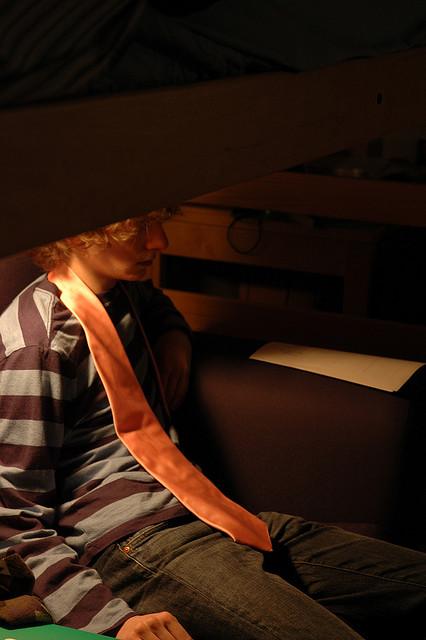What color is the boy's shirt?
Short answer required. Gray and maroon. Is the boy sitting?
Concise answer only. Yes. Is the boy wearing a tie?
Keep it brief. Yes. 